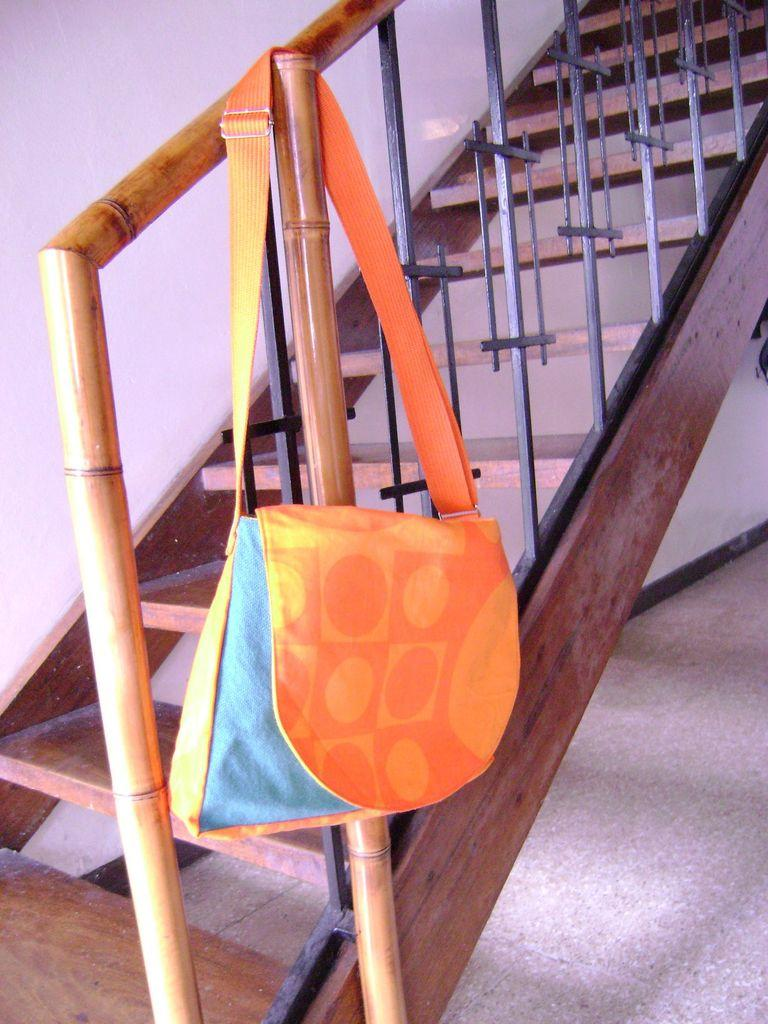What type of stairs are visible in the image? There are wooden stairs in the image. What direction are the wooden stairs going? The wooden stairs are going upwards. What material is the grill on the wooden stairs made of? The grill on the wooden stairs is made of black iron. What is hanging on the black iron grill? An orange bag is hanging on the black iron grill. What type of church is visible in the image? There is no church present in the image. What hobbies are the people in the image engaged in? There are no people visible in the image, so their hobbies cannot be determined. 